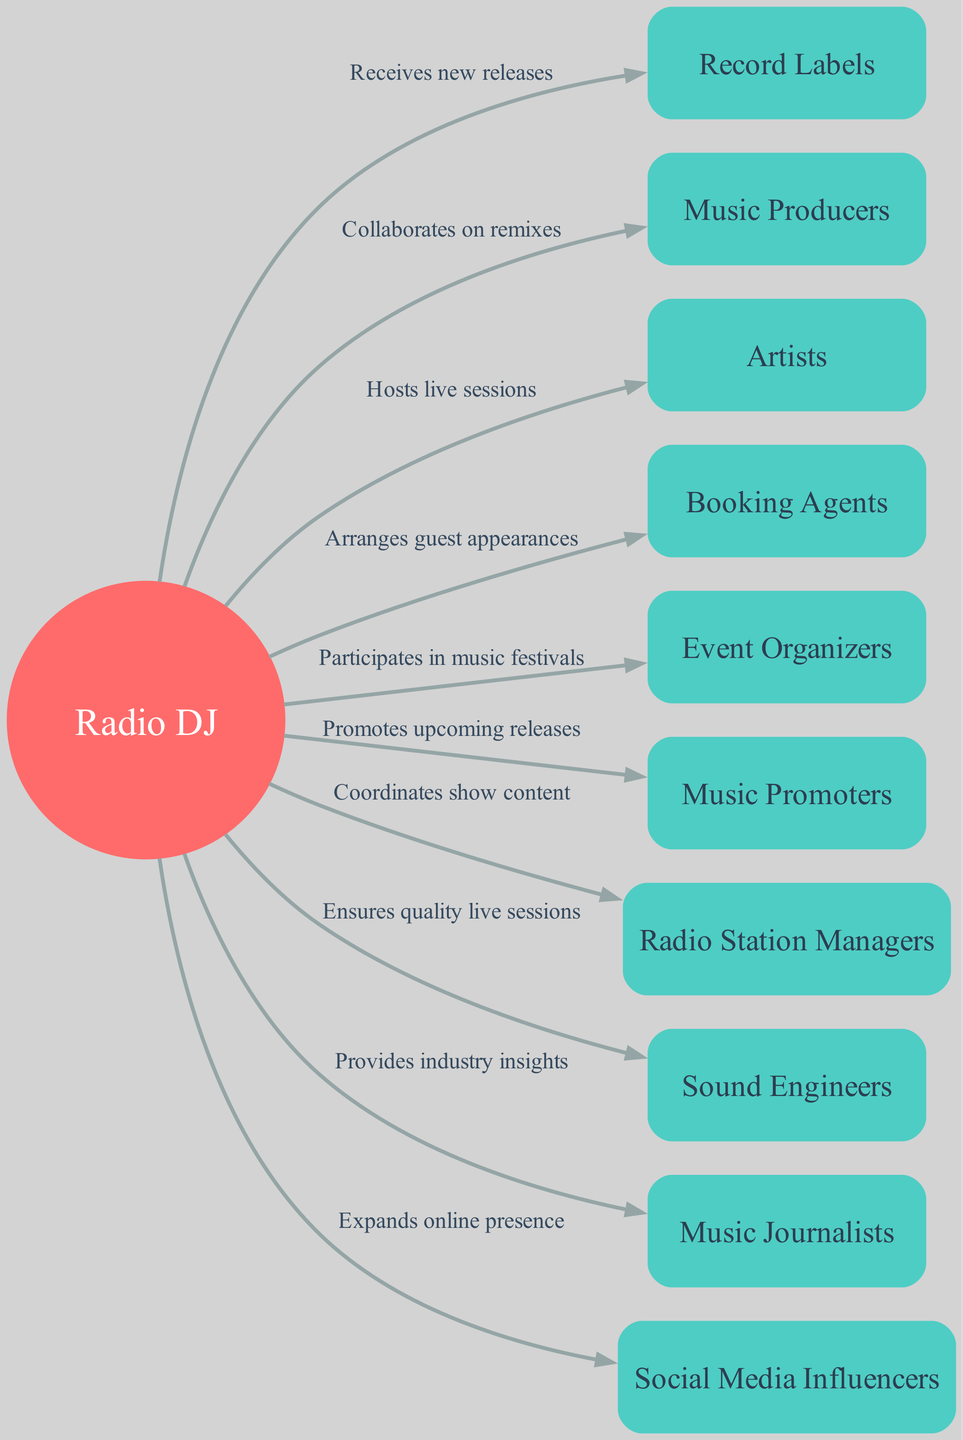What's the central node of the diagram? The central node is indicated at the center of the diagram as "Radio DJ."
Answer: Radio DJ How many nodes are there in the diagram? Counting all unique entities shown, there are a total of 10 nodes including the central node.
Answer: 10 What is the role of Booking Agents in the DJ's career? The connection labeled "Arranges guest appearances" connects "Radio DJ" to "Booking Agents," indicating their role in arranging appearances for the DJ.
Answer: Arranges guest appearances Which node is connected to the Radio DJ by the label "Ensures quality live sessions"? The label indicates a connection from "Radio DJ" to "Sound Engineers," showing their role in ensuring quality during live sessions.
Answer: Sound Engineers What connections involve collaboration? There are connections "Collaborates on remixes" and "Hosts live sessions" that involve collaboration between the Radio DJ and Music Producers, and Artists respectively.
Answer: Collaborates on remixes, Hosts live sessions How does the Radio DJ interact with Music Promoters? The connection labeled "Promotes upcoming releases" shows that the Radio DJ interacts with Music Promoters in the context of promoting music releases.
Answer: Promotes upcoming releases What is the relationship between the Radio DJ and Social Media Influencers? The label "Expands online presence" illustrates that Social Media Influencers help the Radio DJ with promoting to a broader online audience.
Answer: Expands online presence Which roles help in festival participation? The connection from "Radio DJ" to "Event Organizers" is labeled "Participates in music festivals," indicating their role in organizing events where the DJ participates.
Answer: Event Organizers What type of insights does the Radio DJ provide to Music Journalists? The relationship labeled "Provides industry insights" reveals that the Radio DJ shares valuable knowledge and perspectives about the music industry with Music Journalists.
Answer: Provides industry insights 